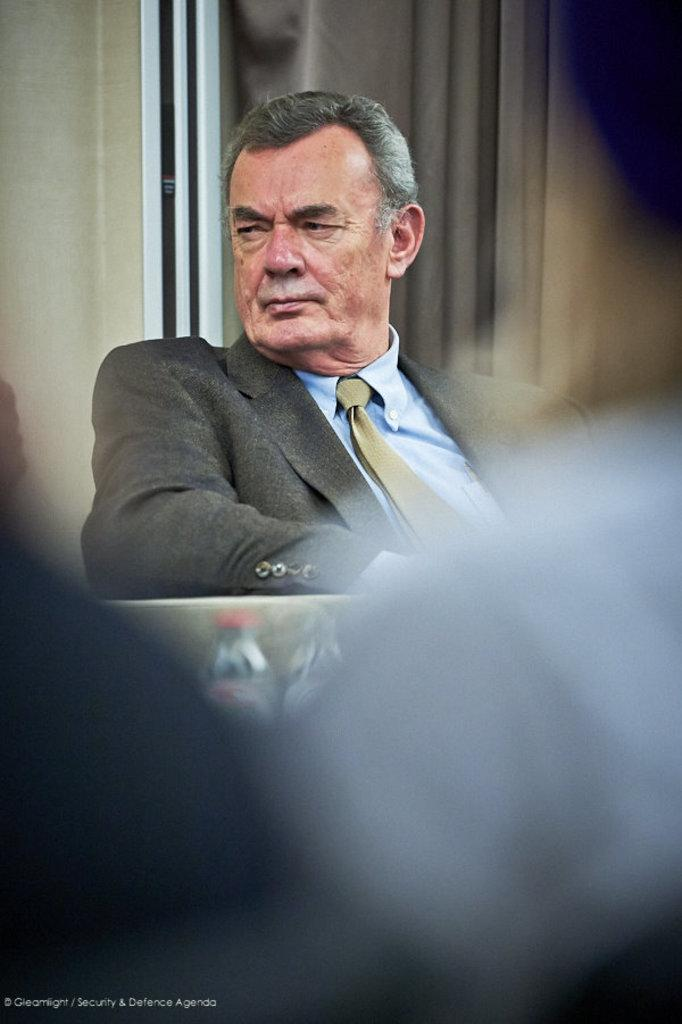What is the person in the image doing? The person is sitting in the image. What type of clothing is the person wearing on their upper body? The person is wearing a gray color blazer and a blue shirt. Is the person wearing any accessories around their neck? Yes, the person is wearing a tie. What color is the wall in the background of the image? The wall in the background of the image is cream colored. How many sticks can be seen in the image? There are no sticks present in the image. Is there a hill visible in the background of the image? There is no hill visible in the image; the background only includes a cream-colored wall. 